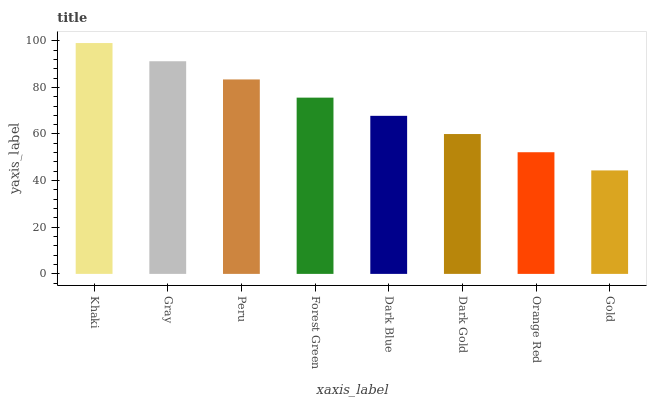Is Gold the minimum?
Answer yes or no. Yes. Is Khaki the maximum?
Answer yes or no. Yes. Is Gray the minimum?
Answer yes or no. No. Is Gray the maximum?
Answer yes or no. No. Is Khaki greater than Gray?
Answer yes or no. Yes. Is Gray less than Khaki?
Answer yes or no. Yes. Is Gray greater than Khaki?
Answer yes or no. No. Is Khaki less than Gray?
Answer yes or no. No. Is Forest Green the high median?
Answer yes or no. Yes. Is Dark Blue the low median?
Answer yes or no. Yes. Is Orange Red the high median?
Answer yes or no. No. Is Peru the low median?
Answer yes or no. No. 